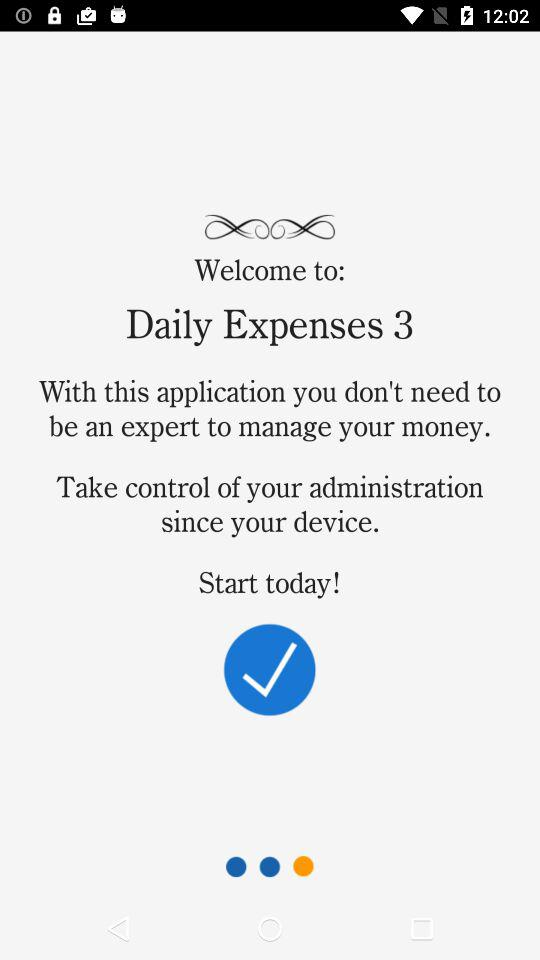What is the name of the application? The name of the application is "Daily Expenses 3". 